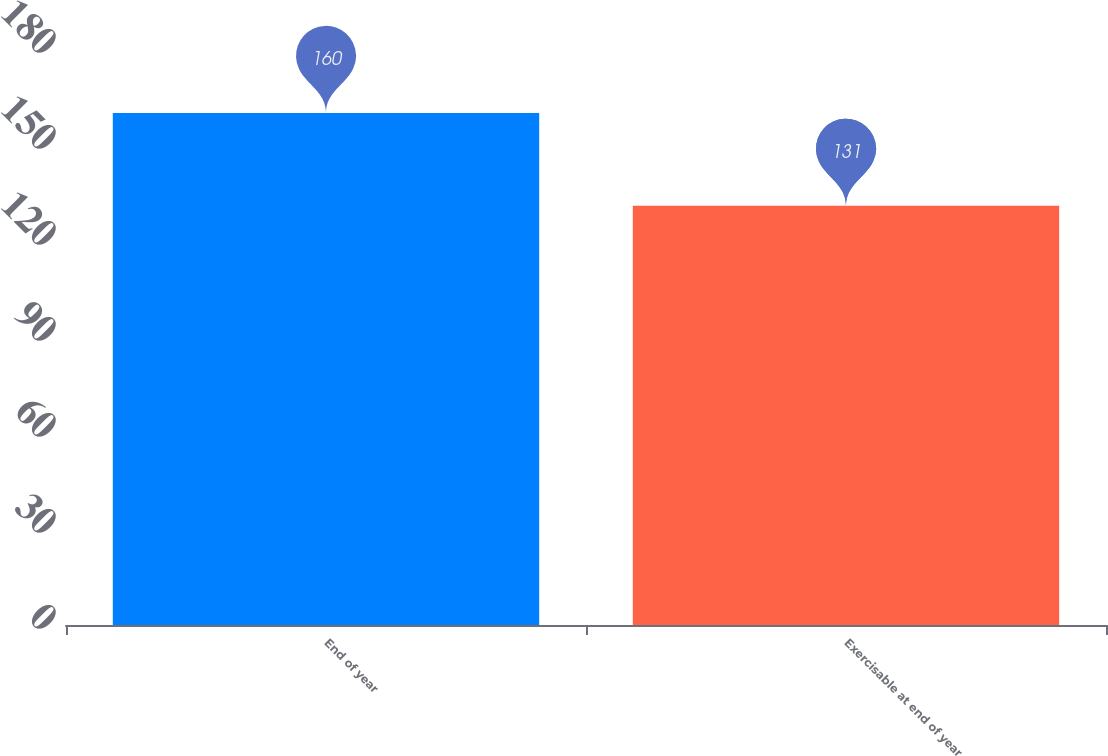<chart> <loc_0><loc_0><loc_500><loc_500><bar_chart><fcel>End of year<fcel>Exercisable at end of year<nl><fcel>160<fcel>131<nl></chart> 